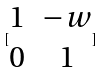<formula> <loc_0><loc_0><loc_500><loc_500>[ \begin{matrix} 1 & - w \\ 0 & 1 \end{matrix} ]</formula> 